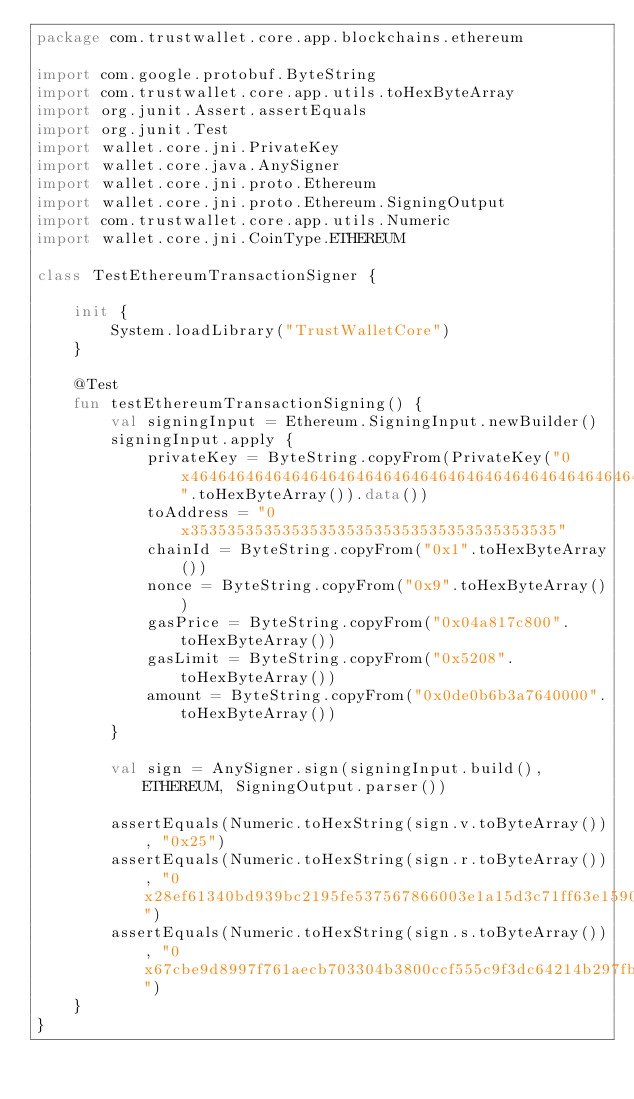Convert code to text. <code><loc_0><loc_0><loc_500><loc_500><_Kotlin_>package com.trustwallet.core.app.blockchains.ethereum

import com.google.protobuf.ByteString
import com.trustwallet.core.app.utils.toHexByteArray
import org.junit.Assert.assertEquals
import org.junit.Test
import wallet.core.jni.PrivateKey
import wallet.core.java.AnySigner
import wallet.core.jni.proto.Ethereum
import wallet.core.jni.proto.Ethereum.SigningOutput
import com.trustwallet.core.app.utils.Numeric
import wallet.core.jni.CoinType.ETHEREUM

class TestEthereumTransactionSigner {

    init {
        System.loadLibrary("TrustWalletCore")
    }

    @Test
    fun testEthereumTransactionSigning() {
        val signingInput = Ethereum.SigningInput.newBuilder()
        signingInput.apply {
            privateKey = ByteString.copyFrom(PrivateKey("0x4646464646464646464646464646464646464646464646464646464646464646".toHexByteArray()).data())
            toAddress = "0x3535353535353535353535353535353535353535"
            chainId = ByteString.copyFrom("0x1".toHexByteArray())
            nonce = ByteString.copyFrom("0x9".toHexByteArray())
            gasPrice = ByteString.copyFrom("0x04a817c800".toHexByteArray())
            gasLimit = ByteString.copyFrom("0x5208".toHexByteArray())
            amount = ByteString.copyFrom("0x0de0b6b3a7640000".toHexByteArray())
        }

        val sign = AnySigner.sign(signingInput.build(), ETHEREUM, SigningOutput.parser())

        assertEquals(Numeric.toHexString(sign.v.toByteArray()), "0x25")
        assertEquals(Numeric.toHexString(sign.r.toByteArray()), "0x28ef61340bd939bc2195fe537567866003e1a15d3c71ff63e1590620aa636276")
        assertEquals(Numeric.toHexString(sign.s.toByteArray()), "0x67cbe9d8997f761aecb703304b3800ccf555c9f3dc64214b297fb1966a3b6d83")
    }
}
</code> 